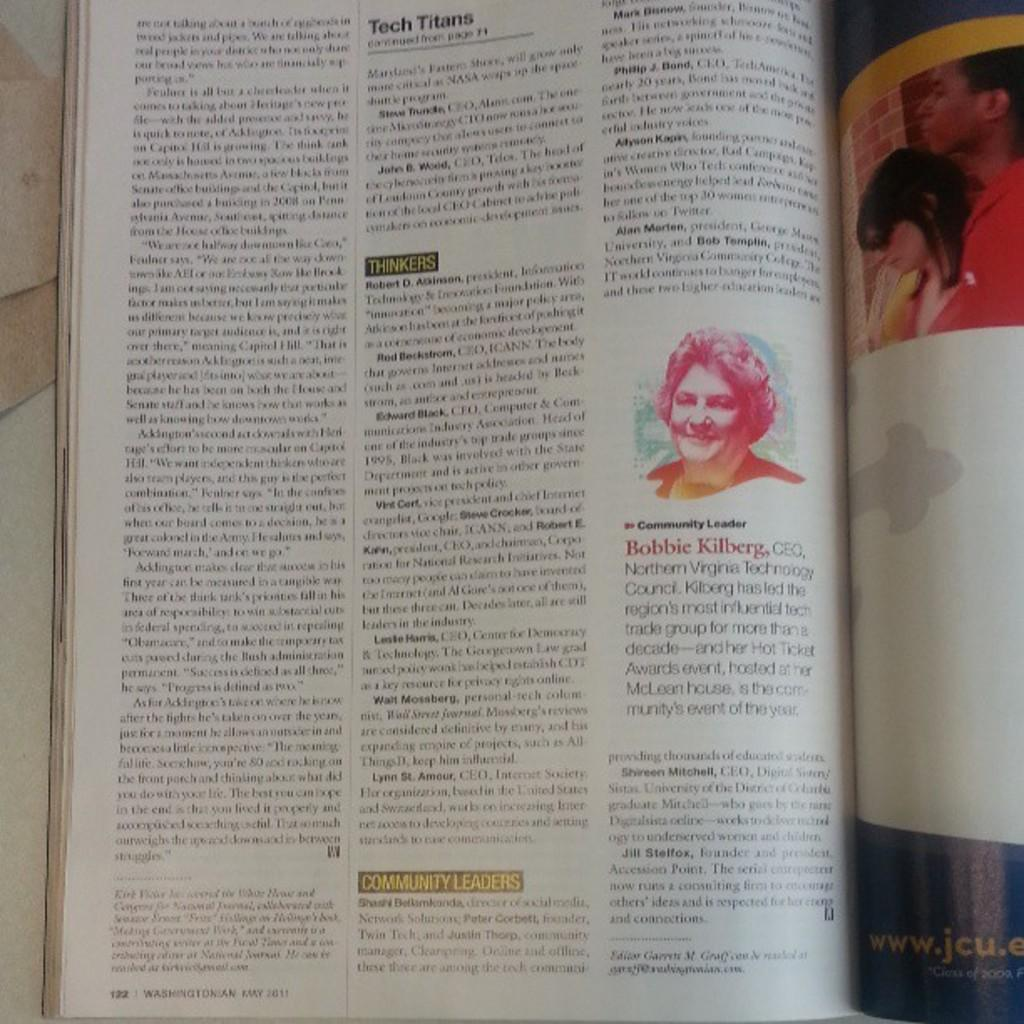What object can be seen in the image? There is a book in the image. Where is the book located? The book is on the floor. What type of content does the book have? The book contains text and pictures. What type of string is used to hold the book on the stage in the image? There is no string or stage present in the image; it only features a book on the floor. 